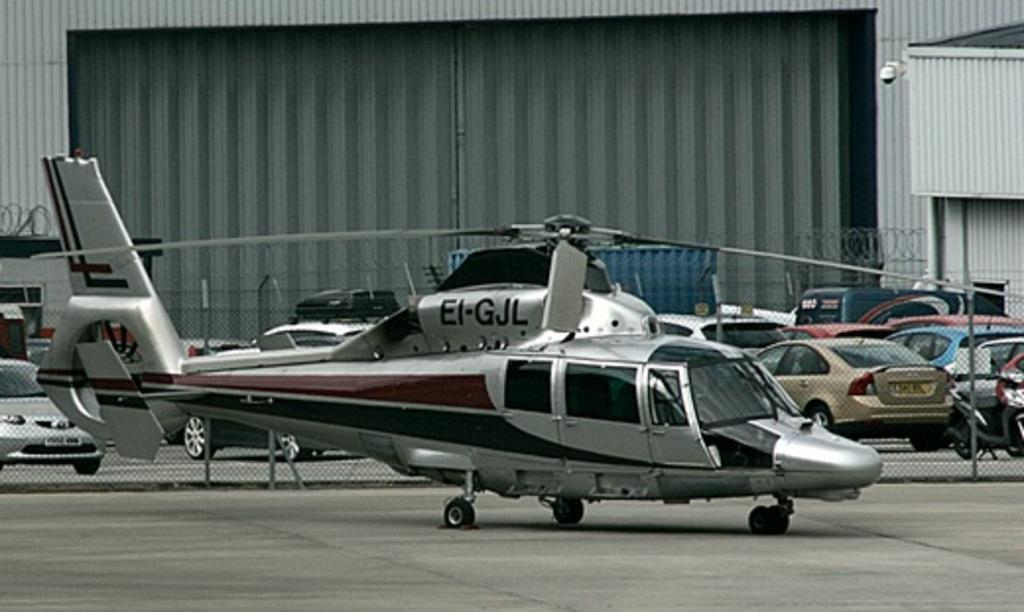What is the main subject in the foreground of the image? There is a helicopter on the surface in the foreground of the image. What can be seen in the background of the image? In the background of the image, there is fencing, vehicles, a wall, and a gate. Can you describe the fence in the image? The fence is in the background of the image, but no specific details about its appearance are provided. What type of structure is the gate a part of? The gate is in the background of the image, and it is part of a wall. What word is being taught in the image? There is no indication in the image that a word is being taught or learned. 